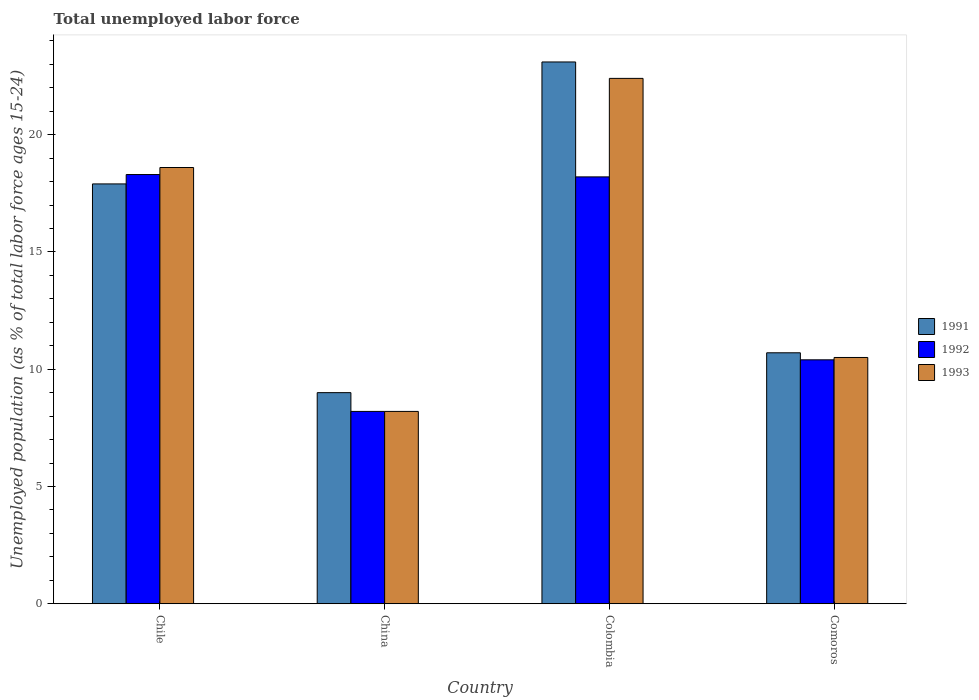How many different coloured bars are there?
Your response must be concise. 3. Are the number of bars on each tick of the X-axis equal?
Provide a succinct answer. Yes. What is the label of the 2nd group of bars from the left?
Your answer should be compact. China. In how many cases, is the number of bars for a given country not equal to the number of legend labels?
Offer a very short reply. 0. What is the percentage of unemployed population in in 1993 in Colombia?
Make the answer very short. 22.4. Across all countries, what is the maximum percentage of unemployed population in in 1991?
Give a very brief answer. 23.1. Across all countries, what is the minimum percentage of unemployed population in in 1992?
Provide a succinct answer. 8.2. In which country was the percentage of unemployed population in in 1991 maximum?
Offer a very short reply. Colombia. In which country was the percentage of unemployed population in in 1993 minimum?
Offer a very short reply. China. What is the total percentage of unemployed population in in 1993 in the graph?
Your answer should be compact. 59.7. What is the difference between the percentage of unemployed population in in 1993 in China and that in Colombia?
Offer a terse response. -14.2. What is the difference between the percentage of unemployed population in in 1991 in Colombia and the percentage of unemployed population in in 1993 in Chile?
Offer a very short reply. 4.5. What is the average percentage of unemployed population in in 1993 per country?
Provide a short and direct response. 14.92. What is the difference between the percentage of unemployed population in of/in 1991 and percentage of unemployed population in of/in 1993 in Chile?
Your response must be concise. -0.7. What is the ratio of the percentage of unemployed population in in 1992 in Chile to that in Comoros?
Your answer should be compact. 1.76. What is the difference between the highest and the second highest percentage of unemployed population in in 1993?
Ensure brevity in your answer.  8.1. What is the difference between the highest and the lowest percentage of unemployed population in in 1991?
Give a very brief answer. 14.1. In how many countries, is the percentage of unemployed population in in 1992 greater than the average percentage of unemployed population in in 1992 taken over all countries?
Offer a very short reply. 2. Is it the case that in every country, the sum of the percentage of unemployed population in in 1992 and percentage of unemployed population in in 1993 is greater than the percentage of unemployed population in in 1991?
Provide a succinct answer. Yes. How many countries are there in the graph?
Your answer should be compact. 4. How many legend labels are there?
Offer a very short reply. 3. How are the legend labels stacked?
Your answer should be very brief. Vertical. What is the title of the graph?
Provide a short and direct response. Total unemployed labor force. What is the label or title of the X-axis?
Offer a very short reply. Country. What is the label or title of the Y-axis?
Provide a short and direct response. Unemployed population (as % of total labor force ages 15-24). What is the Unemployed population (as % of total labor force ages 15-24) in 1991 in Chile?
Your response must be concise. 17.9. What is the Unemployed population (as % of total labor force ages 15-24) of 1992 in Chile?
Provide a succinct answer. 18.3. What is the Unemployed population (as % of total labor force ages 15-24) in 1993 in Chile?
Offer a terse response. 18.6. What is the Unemployed population (as % of total labor force ages 15-24) in 1991 in China?
Make the answer very short. 9. What is the Unemployed population (as % of total labor force ages 15-24) in 1992 in China?
Offer a very short reply. 8.2. What is the Unemployed population (as % of total labor force ages 15-24) of 1993 in China?
Offer a terse response. 8.2. What is the Unemployed population (as % of total labor force ages 15-24) of 1991 in Colombia?
Your response must be concise. 23.1. What is the Unemployed population (as % of total labor force ages 15-24) in 1992 in Colombia?
Offer a terse response. 18.2. What is the Unemployed population (as % of total labor force ages 15-24) of 1993 in Colombia?
Your answer should be compact. 22.4. What is the Unemployed population (as % of total labor force ages 15-24) of 1991 in Comoros?
Your answer should be very brief. 10.7. What is the Unemployed population (as % of total labor force ages 15-24) of 1992 in Comoros?
Offer a very short reply. 10.4. Across all countries, what is the maximum Unemployed population (as % of total labor force ages 15-24) in 1991?
Make the answer very short. 23.1. Across all countries, what is the maximum Unemployed population (as % of total labor force ages 15-24) in 1992?
Make the answer very short. 18.3. Across all countries, what is the maximum Unemployed population (as % of total labor force ages 15-24) in 1993?
Make the answer very short. 22.4. Across all countries, what is the minimum Unemployed population (as % of total labor force ages 15-24) of 1992?
Give a very brief answer. 8.2. Across all countries, what is the minimum Unemployed population (as % of total labor force ages 15-24) in 1993?
Keep it short and to the point. 8.2. What is the total Unemployed population (as % of total labor force ages 15-24) of 1991 in the graph?
Provide a short and direct response. 60.7. What is the total Unemployed population (as % of total labor force ages 15-24) of 1992 in the graph?
Your response must be concise. 55.1. What is the total Unemployed population (as % of total labor force ages 15-24) of 1993 in the graph?
Offer a terse response. 59.7. What is the difference between the Unemployed population (as % of total labor force ages 15-24) of 1991 in Chile and that in China?
Keep it short and to the point. 8.9. What is the difference between the Unemployed population (as % of total labor force ages 15-24) in 1992 in Chile and that in China?
Provide a short and direct response. 10.1. What is the difference between the Unemployed population (as % of total labor force ages 15-24) of 1993 in Chile and that in China?
Provide a succinct answer. 10.4. What is the difference between the Unemployed population (as % of total labor force ages 15-24) of 1991 in Chile and that in Colombia?
Your answer should be very brief. -5.2. What is the difference between the Unemployed population (as % of total labor force ages 15-24) of 1993 in Chile and that in Comoros?
Offer a very short reply. 8.1. What is the difference between the Unemployed population (as % of total labor force ages 15-24) in 1991 in China and that in Colombia?
Offer a very short reply. -14.1. What is the difference between the Unemployed population (as % of total labor force ages 15-24) of 1993 in China and that in Colombia?
Your answer should be compact. -14.2. What is the difference between the Unemployed population (as % of total labor force ages 15-24) of 1991 in Colombia and that in Comoros?
Your answer should be very brief. 12.4. What is the difference between the Unemployed population (as % of total labor force ages 15-24) in 1991 in Chile and the Unemployed population (as % of total labor force ages 15-24) in 1993 in Colombia?
Offer a terse response. -4.5. What is the difference between the Unemployed population (as % of total labor force ages 15-24) of 1992 in Chile and the Unemployed population (as % of total labor force ages 15-24) of 1993 in Colombia?
Offer a very short reply. -4.1. What is the difference between the Unemployed population (as % of total labor force ages 15-24) in 1992 in Chile and the Unemployed population (as % of total labor force ages 15-24) in 1993 in Comoros?
Your response must be concise. 7.8. What is the difference between the Unemployed population (as % of total labor force ages 15-24) in 1991 in China and the Unemployed population (as % of total labor force ages 15-24) in 1992 in Colombia?
Ensure brevity in your answer.  -9.2. What is the difference between the Unemployed population (as % of total labor force ages 15-24) of 1992 in China and the Unemployed population (as % of total labor force ages 15-24) of 1993 in Colombia?
Your answer should be very brief. -14.2. What is the difference between the Unemployed population (as % of total labor force ages 15-24) in 1991 in China and the Unemployed population (as % of total labor force ages 15-24) in 1992 in Comoros?
Offer a terse response. -1.4. What is the difference between the Unemployed population (as % of total labor force ages 15-24) of 1991 in China and the Unemployed population (as % of total labor force ages 15-24) of 1993 in Comoros?
Your answer should be very brief. -1.5. What is the difference between the Unemployed population (as % of total labor force ages 15-24) in 1992 in China and the Unemployed population (as % of total labor force ages 15-24) in 1993 in Comoros?
Your answer should be compact. -2.3. What is the average Unemployed population (as % of total labor force ages 15-24) of 1991 per country?
Offer a terse response. 15.18. What is the average Unemployed population (as % of total labor force ages 15-24) of 1992 per country?
Make the answer very short. 13.78. What is the average Unemployed population (as % of total labor force ages 15-24) of 1993 per country?
Offer a terse response. 14.93. What is the difference between the Unemployed population (as % of total labor force ages 15-24) of 1991 and Unemployed population (as % of total labor force ages 15-24) of 1992 in Chile?
Provide a succinct answer. -0.4. What is the difference between the Unemployed population (as % of total labor force ages 15-24) of 1991 and Unemployed population (as % of total labor force ages 15-24) of 1993 in China?
Provide a short and direct response. 0.8. What is the difference between the Unemployed population (as % of total labor force ages 15-24) in 1991 and Unemployed population (as % of total labor force ages 15-24) in 1993 in Colombia?
Offer a very short reply. 0.7. What is the difference between the Unemployed population (as % of total labor force ages 15-24) of 1991 and Unemployed population (as % of total labor force ages 15-24) of 1992 in Comoros?
Offer a terse response. 0.3. What is the difference between the Unemployed population (as % of total labor force ages 15-24) of 1991 and Unemployed population (as % of total labor force ages 15-24) of 1993 in Comoros?
Ensure brevity in your answer.  0.2. What is the ratio of the Unemployed population (as % of total labor force ages 15-24) in 1991 in Chile to that in China?
Offer a terse response. 1.99. What is the ratio of the Unemployed population (as % of total labor force ages 15-24) in 1992 in Chile to that in China?
Your answer should be very brief. 2.23. What is the ratio of the Unemployed population (as % of total labor force ages 15-24) of 1993 in Chile to that in China?
Offer a very short reply. 2.27. What is the ratio of the Unemployed population (as % of total labor force ages 15-24) in 1991 in Chile to that in Colombia?
Your response must be concise. 0.77. What is the ratio of the Unemployed population (as % of total labor force ages 15-24) in 1992 in Chile to that in Colombia?
Your response must be concise. 1.01. What is the ratio of the Unemployed population (as % of total labor force ages 15-24) in 1993 in Chile to that in Colombia?
Make the answer very short. 0.83. What is the ratio of the Unemployed population (as % of total labor force ages 15-24) of 1991 in Chile to that in Comoros?
Your answer should be very brief. 1.67. What is the ratio of the Unemployed population (as % of total labor force ages 15-24) of 1992 in Chile to that in Comoros?
Your answer should be compact. 1.76. What is the ratio of the Unemployed population (as % of total labor force ages 15-24) of 1993 in Chile to that in Comoros?
Your answer should be compact. 1.77. What is the ratio of the Unemployed population (as % of total labor force ages 15-24) in 1991 in China to that in Colombia?
Provide a succinct answer. 0.39. What is the ratio of the Unemployed population (as % of total labor force ages 15-24) in 1992 in China to that in Colombia?
Provide a succinct answer. 0.45. What is the ratio of the Unemployed population (as % of total labor force ages 15-24) of 1993 in China to that in Colombia?
Ensure brevity in your answer.  0.37. What is the ratio of the Unemployed population (as % of total labor force ages 15-24) in 1991 in China to that in Comoros?
Make the answer very short. 0.84. What is the ratio of the Unemployed population (as % of total labor force ages 15-24) in 1992 in China to that in Comoros?
Give a very brief answer. 0.79. What is the ratio of the Unemployed population (as % of total labor force ages 15-24) of 1993 in China to that in Comoros?
Provide a short and direct response. 0.78. What is the ratio of the Unemployed population (as % of total labor force ages 15-24) of 1991 in Colombia to that in Comoros?
Ensure brevity in your answer.  2.16. What is the ratio of the Unemployed population (as % of total labor force ages 15-24) of 1992 in Colombia to that in Comoros?
Offer a very short reply. 1.75. What is the ratio of the Unemployed population (as % of total labor force ages 15-24) in 1993 in Colombia to that in Comoros?
Your answer should be compact. 2.13. What is the difference between the highest and the second highest Unemployed population (as % of total labor force ages 15-24) of 1991?
Make the answer very short. 5.2. What is the difference between the highest and the second highest Unemployed population (as % of total labor force ages 15-24) of 1992?
Ensure brevity in your answer.  0.1. What is the difference between the highest and the lowest Unemployed population (as % of total labor force ages 15-24) of 1992?
Your response must be concise. 10.1. What is the difference between the highest and the lowest Unemployed population (as % of total labor force ages 15-24) of 1993?
Offer a terse response. 14.2. 